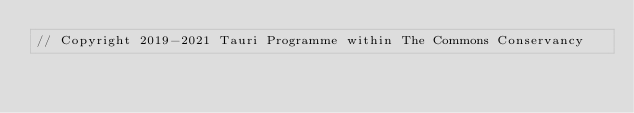Convert code to text. <code><loc_0><loc_0><loc_500><loc_500><_Rust_>// Copyright 2019-2021 Tauri Programme within The Commons Conservancy</code> 